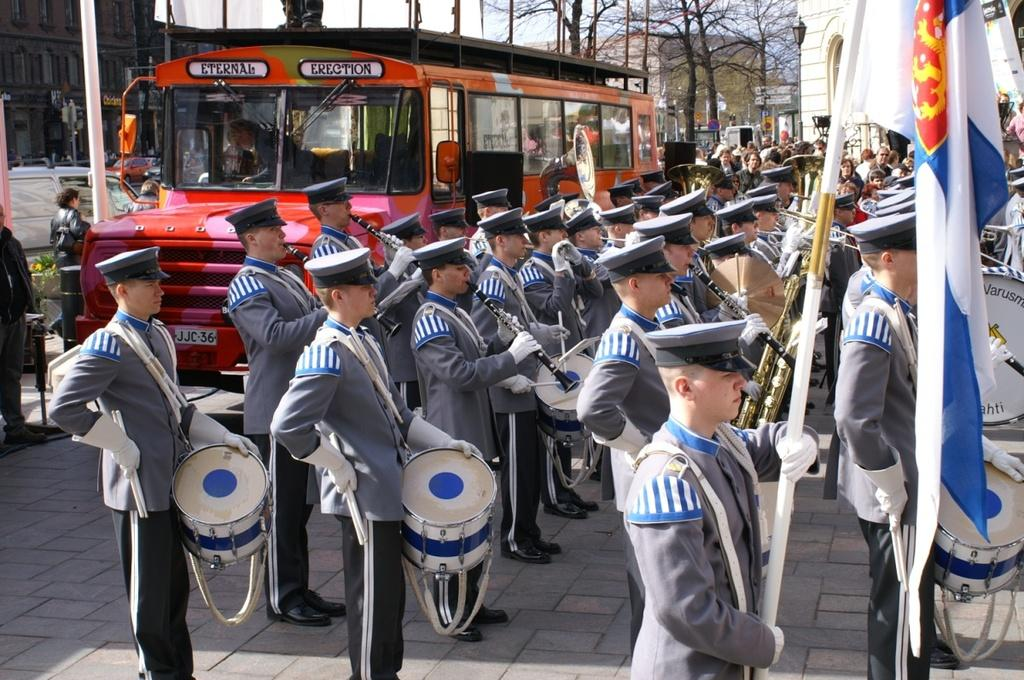What are the people in the image doing? Some of the people are playing musical instruments, and one person is holding a flag. Can you describe the background of the image? There are vehicles, buildings, and trees visible in the background. How many people are playing musical instruments in the image? The number of people playing musical instruments is not specified, but it is mentioned that some people are playing instruments. What type of vehicles can be seen in the background? The specific type of vehicles is not mentioned, but vehicles are visible in the background. What type of dirt is being used to expand the buildings in the image? There is no mention of dirt or expansion in the image; it features people playing musical instruments and holding a flag, with vehicles, buildings, and trees in the background. 